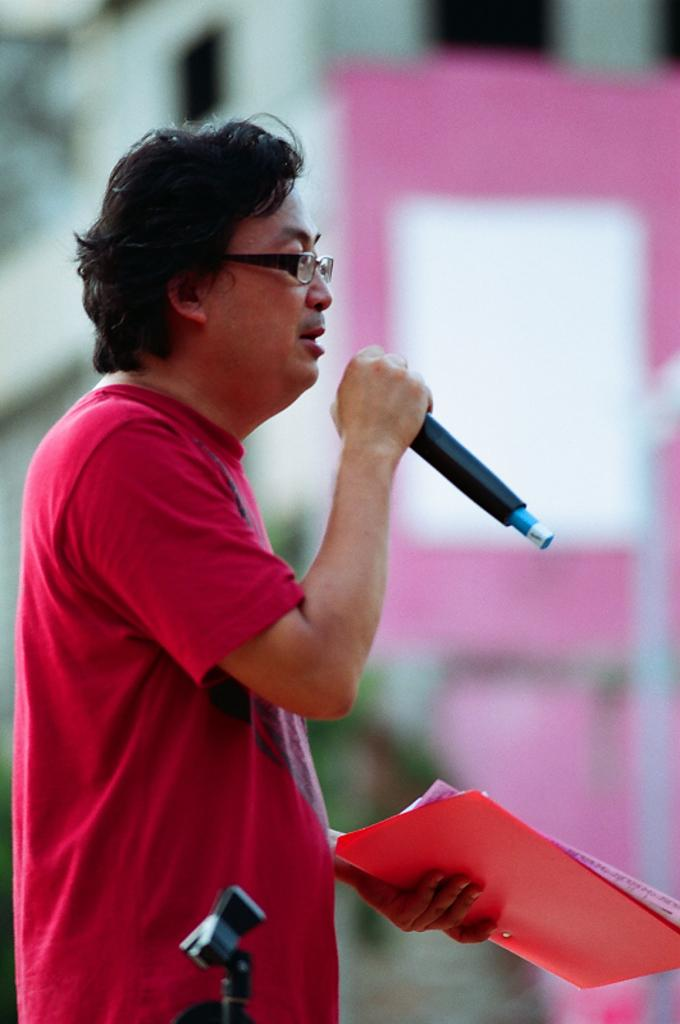What is the main subject of the image? There is a person in the image. What is the person holding in the image? The person is holding some papers. What equipment is present in the image? There is a microphone and a mic stand in the image. Can you describe the background of the image? The background of the image is blurred. What type of holiday is being celebrated in the image? There is no indication of a holiday being celebrated in the image. Can you describe the person's haircut in the image? The person's haircut cannot be determined from the image, as it is not visible or described in the provided facts. 